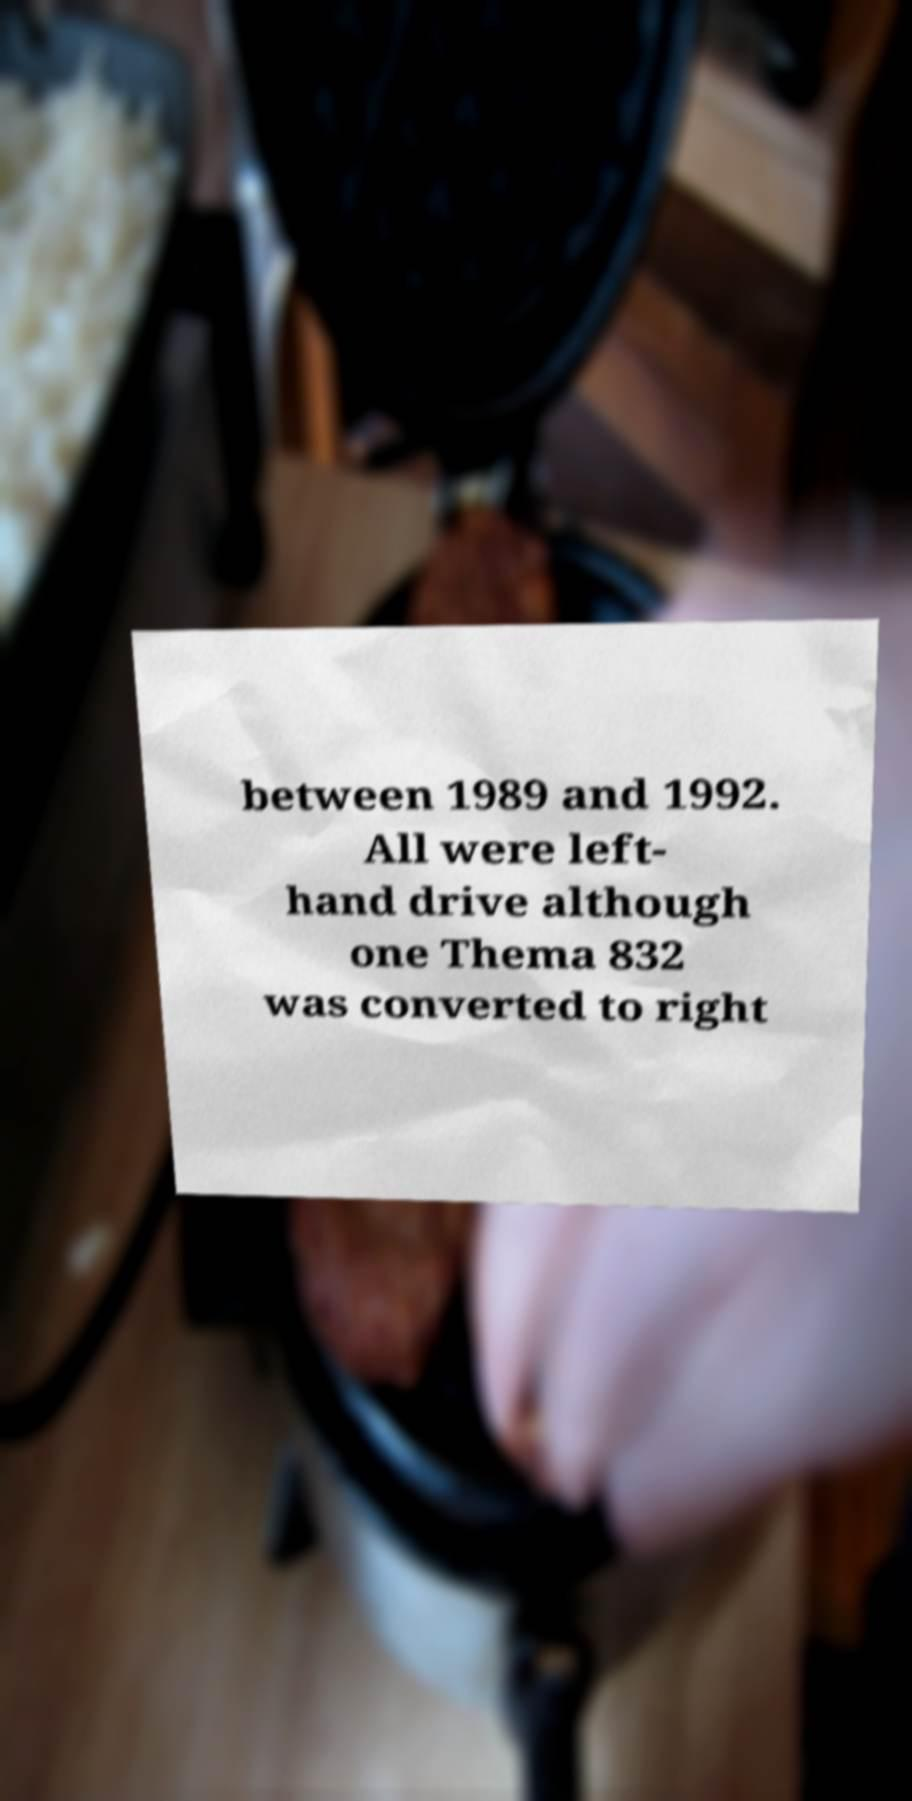Could you extract and type out the text from this image? between 1989 and 1992. All were left- hand drive although one Thema 832 was converted to right 